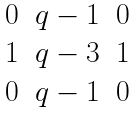<formula> <loc_0><loc_0><loc_500><loc_500>\begin{matrix} 0 & q - 1 & 0 \\ 1 & q - 3 & 1 \\ 0 & q - 1 & 0 \end{matrix}</formula> 